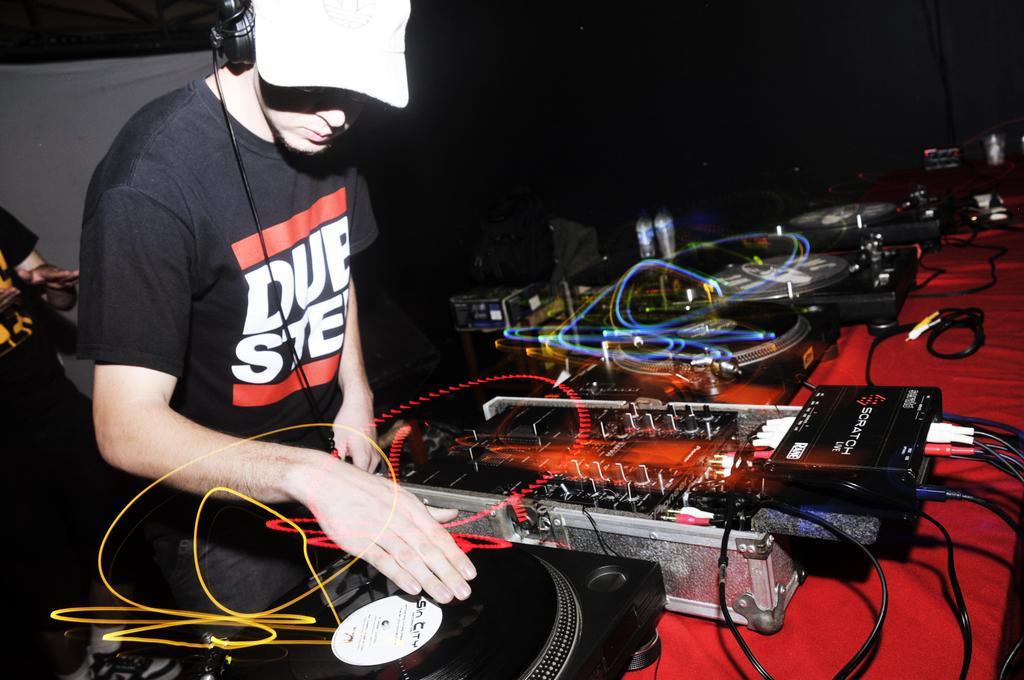Can you describe this image briefly? At the bottom of the image we can see a table, on the table we can see some musical devices. Behind the table a person is standing and holding a musical device. Behind him we can see a person. 